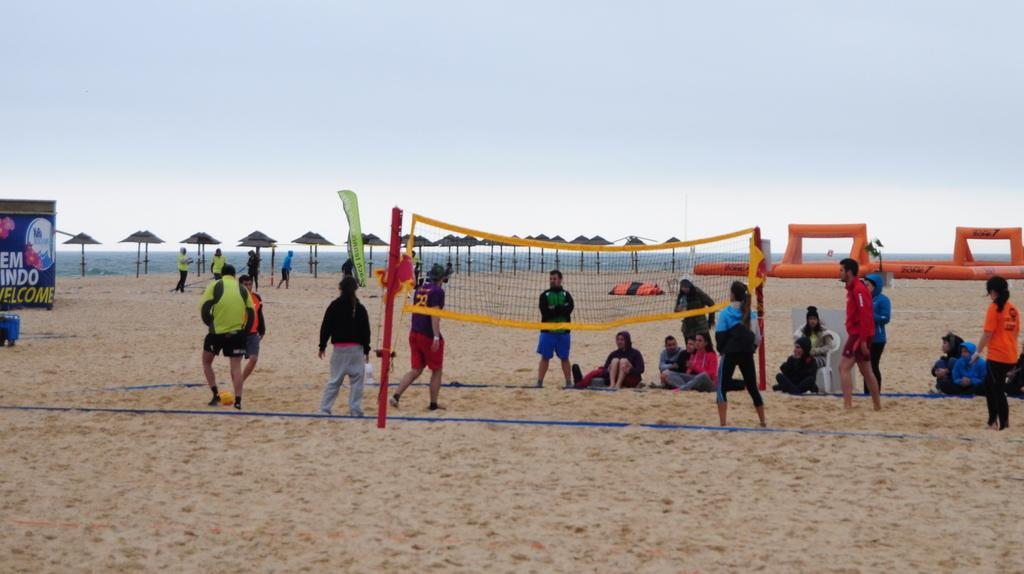What are the people in the image doing? The people in the image are playing games. What is used to separate the playing area in the image? There is a net in the image. What is visible at the top of the image? The sky is visible at the top of the image. What type of jeans are being worn by the square in the image? There is no square or jeans present in the image. What type of blade is being used to cut the net in the image? There is no blade or cutting of the net in the image; the net is used to separate the playing area. 